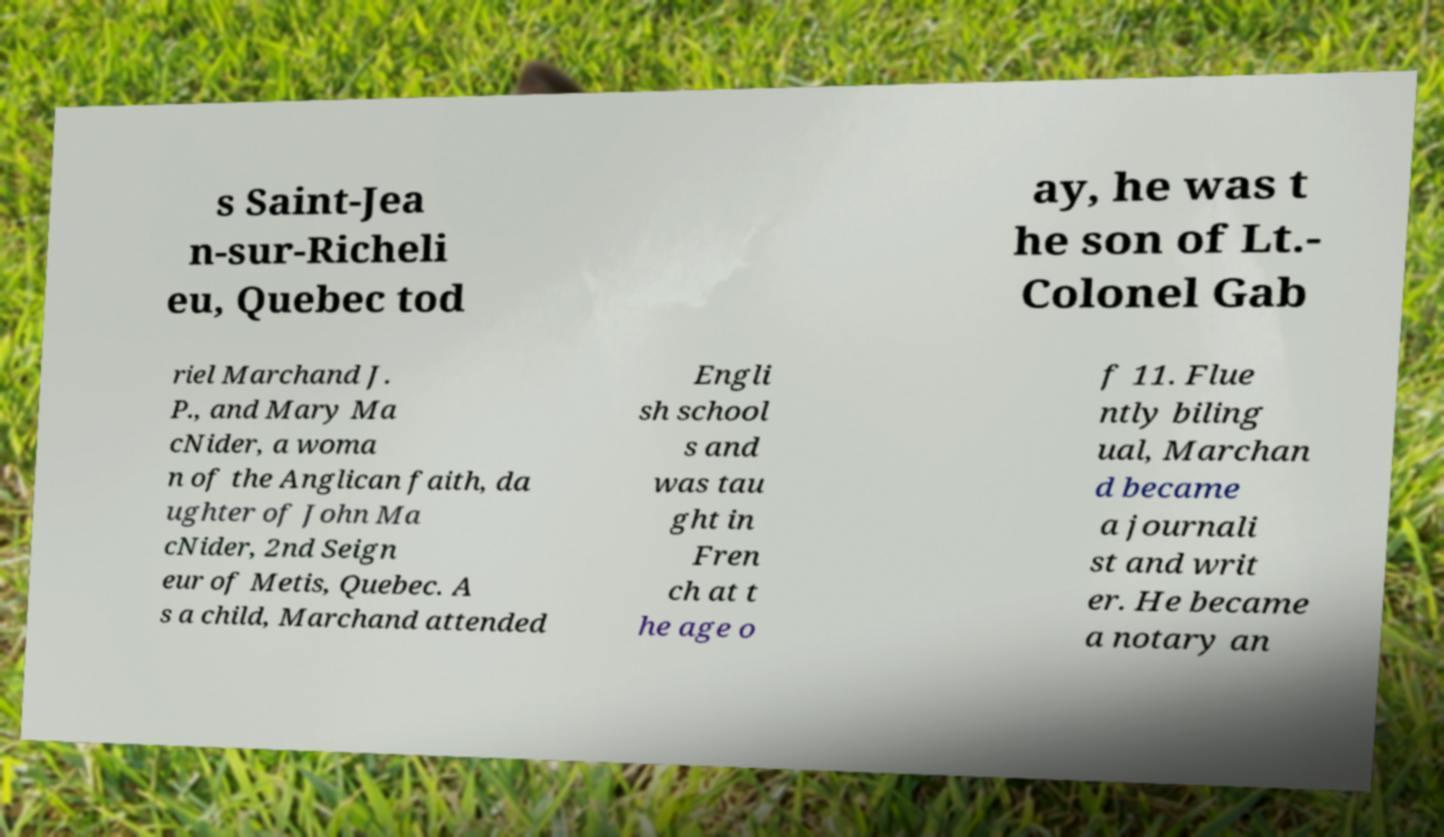Can you accurately transcribe the text from the provided image for me? s Saint-Jea n-sur-Richeli eu, Quebec tod ay, he was t he son of Lt.- Colonel Gab riel Marchand J. P., and Mary Ma cNider, a woma n of the Anglican faith, da ughter of John Ma cNider, 2nd Seign eur of Metis, Quebec. A s a child, Marchand attended Engli sh school s and was tau ght in Fren ch at t he age o f 11. Flue ntly biling ual, Marchan d became a journali st and writ er. He became a notary an 